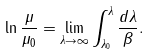Convert formula to latex. <formula><loc_0><loc_0><loc_500><loc_500>\ln \frac { \mu } { \mu _ { 0 } } = \lim _ { \lambda \rightarrow \infty } \int _ { \lambda _ { 0 } } ^ { \lambda } \frac { d \lambda } { \beta } .</formula> 